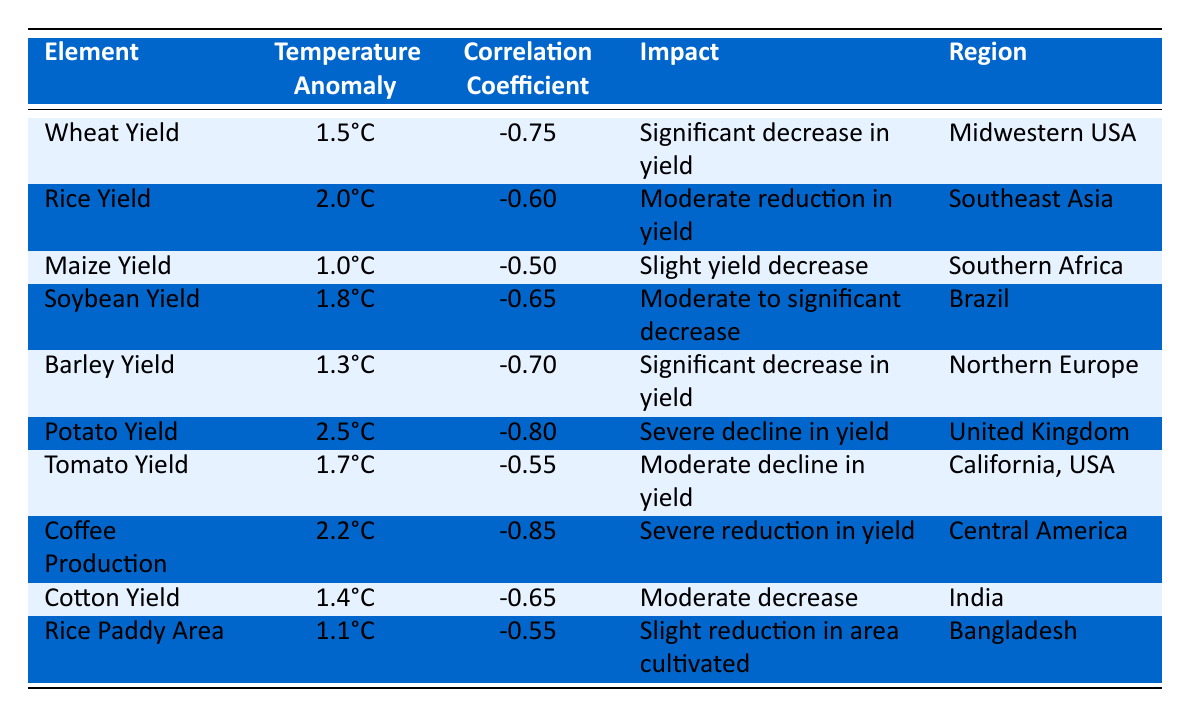What is the correlation coefficient for Potato Yield? Referring to the table, the correlation coefficient for Potato Yield is -0.80.
Answer: -0.80 Which crop shows the most significant decline in yield based on the provided data? In the table, Coffee Production has the highest negative correlation coefficient of -0.85, indicating a severe reduction in yield.
Answer: Coffee Production Is there a yield impact for Rice Yield at a 1.5°C temperature anomaly? The table shows that Rice Yield is associated with a 2.0°C temperature anomaly, not 1.5°C, which means the statement is false.
Answer: No Which region is associated with the greatest temperature anomaly and what is the impact on yield? According to the table, the United Kingdom is associated with a temperature anomaly of 2.5°C and has a severe decline in yield for Potato Yield.
Answer: United Kingdom, severe decline What is the average correlation coefficient for the crops listed in the table? To calculate the average, we sum the correlation coefficients: (-0.75) + (-0.60) + (-0.50) + (-0.65) + (-0.70) + (-0.80) + (-0.55) + (-0.85) + (-0.65) + (-0.55) = -6.75. There are 10 crops, so the average is -6.75 / 10 = -0.675.
Answer: -0.675 